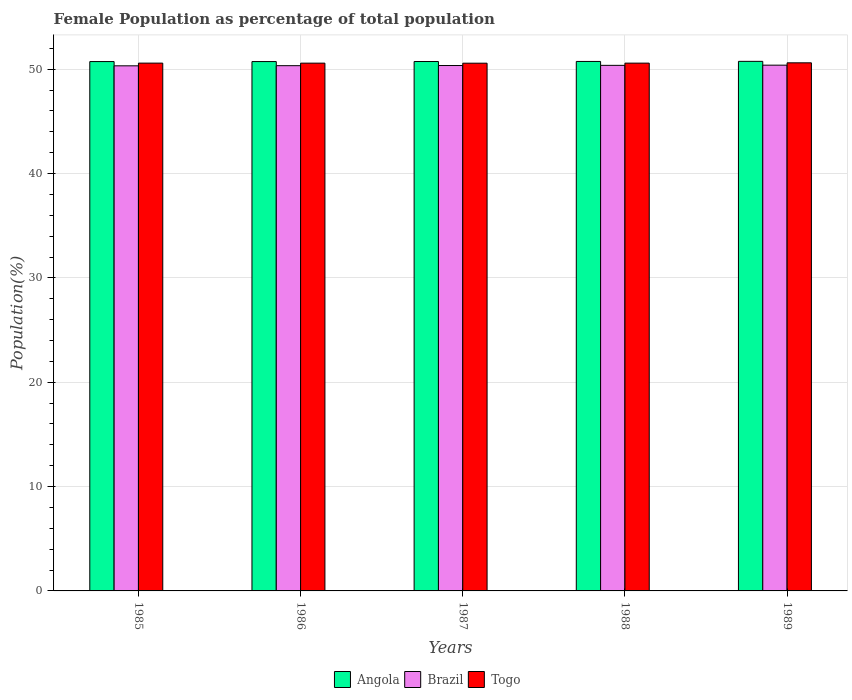Are the number of bars per tick equal to the number of legend labels?
Give a very brief answer. Yes. Are the number of bars on each tick of the X-axis equal?
Ensure brevity in your answer.  Yes. How many bars are there on the 4th tick from the left?
Provide a succinct answer. 3. What is the label of the 5th group of bars from the left?
Offer a very short reply. 1989. What is the female population in in Angola in 1989?
Your answer should be very brief. 50.75. Across all years, what is the maximum female population in in Brazil?
Ensure brevity in your answer.  50.39. Across all years, what is the minimum female population in in Brazil?
Offer a very short reply. 50.32. What is the total female population in in Brazil in the graph?
Keep it short and to the point. 251.77. What is the difference between the female population in in Angola in 1985 and that in 1989?
Provide a short and direct response. -0.02. What is the difference between the female population in in Brazil in 1987 and the female population in in Togo in 1985?
Offer a very short reply. -0.23. What is the average female population in in Angola per year?
Keep it short and to the point. 50.74. In the year 1988, what is the difference between the female population in in Brazil and female population in in Angola?
Ensure brevity in your answer.  -0.37. What is the ratio of the female population in in Brazil in 1985 to that in 1988?
Offer a very short reply. 1. Is the female population in in Angola in 1985 less than that in 1989?
Provide a short and direct response. Yes. Is the difference between the female population in in Brazil in 1985 and 1988 greater than the difference between the female population in in Angola in 1985 and 1988?
Keep it short and to the point. No. What is the difference between the highest and the second highest female population in in Brazil?
Provide a succinct answer. 0.02. What is the difference between the highest and the lowest female population in in Angola?
Your response must be concise. 0.02. Is the sum of the female population in in Angola in 1988 and 1989 greater than the maximum female population in in Brazil across all years?
Keep it short and to the point. Yes. What does the 3rd bar from the left in 1988 represents?
Ensure brevity in your answer.  Togo. What does the 1st bar from the right in 1989 represents?
Your answer should be compact. Togo. What is the difference between two consecutive major ticks on the Y-axis?
Offer a terse response. 10. Does the graph contain grids?
Make the answer very short. Yes. How are the legend labels stacked?
Offer a terse response. Horizontal. What is the title of the graph?
Keep it short and to the point. Female Population as percentage of total population. What is the label or title of the Y-axis?
Offer a very short reply. Population(%). What is the Population(%) of Angola in 1985?
Ensure brevity in your answer.  50.73. What is the Population(%) in Brazil in 1985?
Your answer should be compact. 50.32. What is the Population(%) of Togo in 1985?
Offer a terse response. 50.58. What is the Population(%) of Angola in 1986?
Offer a terse response. 50.73. What is the Population(%) in Brazil in 1986?
Provide a succinct answer. 50.34. What is the Population(%) of Togo in 1986?
Provide a short and direct response. 50.58. What is the Population(%) in Angola in 1987?
Offer a very short reply. 50.74. What is the Population(%) of Brazil in 1987?
Ensure brevity in your answer.  50.35. What is the Population(%) of Togo in 1987?
Your response must be concise. 50.58. What is the Population(%) of Angola in 1988?
Provide a succinct answer. 50.74. What is the Population(%) of Brazil in 1988?
Make the answer very short. 50.37. What is the Population(%) in Togo in 1988?
Your answer should be compact. 50.58. What is the Population(%) in Angola in 1989?
Provide a short and direct response. 50.75. What is the Population(%) in Brazil in 1989?
Your answer should be compact. 50.39. What is the Population(%) in Togo in 1989?
Provide a short and direct response. 50.61. Across all years, what is the maximum Population(%) of Angola?
Provide a succinct answer. 50.75. Across all years, what is the maximum Population(%) of Brazil?
Your answer should be compact. 50.39. Across all years, what is the maximum Population(%) in Togo?
Your response must be concise. 50.61. Across all years, what is the minimum Population(%) in Angola?
Ensure brevity in your answer.  50.73. Across all years, what is the minimum Population(%) in Brazil?
Offer a terse response. 50.32. Across all years, what is the minimum Population(%) in Togo?
Offer a very short reply. 50.58. What is the total Population(%) of Angola in the graph?
Your answer should be compact. 253.7. What is the total Population(%) in Brazil in the graph?
Your answer should be very brief. 251.77. What is the total Population(%) of Togo in the graph?
Give a very brief answer. 252.93. What is the difference between the Population(%) of Brazil in 1985 and that in 1986?
Offer a terse response. -0.01. What is the difference between the Population(%) in Togo in 1985 and that in 1986?
Give a very brief answer. 0. What is the difference between the Population(%) in Angola in 1985 and that in 1987?
Offer a terse response. -0. What is the difference between the Population(%) in Brazil in 1985 and that in 1987?
Ensure brevity in your answer.  -0.03. What is the difference between the Population(%) of Togo in 1985 and that in 1987?
Your answer should be compact. 0.01. What is the difference between the Population(%) in Angola in 1985 and that in 1988?
Offer a terse response. -0.01. What is the difference between the Population(%) of Brazil in 1985 and that in 1988?
Make the answer very short. -0.05. What is the difference between the Population(%) of Togo in 1985 and that in 1988?
Offer a terse response. 0. What is the difference between the Population(%) of Angola in 1985 and that in 1989?
Provide a succinct answer. -0.02. What is the difference between the Population(%) in Brazil in 1985 and that in 1989?
Your response must be concise. -0.06. What is the difference between the Population(%) of Togo in 1985 and that in 1989?
Your answer should be compact. -0.03. What is the difference between the Population(%) in Angola in 1986 and that in 1987?
Provide a short and direct response. -0. What is the difference between the Population(%) of Brazil in 1986 and that in 1987?
Make the answer very short. -0.02. What is the difference between the Population(%) in Togo in 1986 and that in 1987?
Provide a succinct answer. 0. What is the difference between the Population(%) of Angola in 1986 and that in 1988?
Ensure brevity in your answer.  -0.01. What is the difference between the Population(%) of Brazil in 1986 and that in 1988?
Your response must be concise. -0.03. What is the difference between the Population(%) of Togo in 1986 and that in 1988?
Provide a succinct answer. -0. What is the difference between the Population(%) in Angola in 1986 and that in 1989?
Offer a very short reply. -0.02. What is the difference between the Population(%) of Brazil in 1986 and that in 1989?
Your answer should be compact. -0.05. What is the difference between the Population(%) in Togo in 1986 and that in 1989?
Offer a very short reply. -0.03. What is the difference between the Population(%) of Angola in 1987 and that in 1988?
Give a very brief answer. -0.01. What is the difference between the Population(%) in Brazil in 1987 and that in 1988?
Ensure brevity in your answer.  -0.02. What is the difference between the Population(%) in Togo in 1987 and that in 1988?
Offer a very short reply. -0.01. What is the difference between the Population(%) in Angola in 1987 and that in 1989?
Your answer should be compact. -0.02. What is the difference between the Population(%) of Brazil in 1987 and that in 1989?
Ensure brevity in your answer.  -0.03. What is the difference between the Population(%) in Togo in 1987 and that in 1989?
Offer a very short reply. -0.04. What is the difference between the Population(%) of Angola in 1988 and that in 1989?
Give a very brief answer. -0.01. What is the difference between the Population(%) of Brazil in 1988 and that in 1989?
Give a very brief answer. -0.02. What is the difference between the Population(%) of Togo in 1988 and that in 1989?
Provide a short and direct response. -0.03. What is the difference between the Population(%) of Angola in 1985 and the Population(%) of Brazil in 1986?
Give a very brief answer. 0.39. What is the difference between the Population(%) of Angola in 1985 and the Population(%) of Togo in 1986?
Your response must be concise. 0.15. What is the difference between the Population(%) in Brazil in 1985 and the Population(%) in Togo in 1986?
Keep it short and to the point. -0.26. What is the difference between the Population(%) in Angola in 1985 and the Population(%) in Brazil in 1987?
Ensure brevity in your answer.  0.38. What is the difference between the Population(%) of Angola in 1985 and the Population(%) of Togo in 1987?
Provide a succinct answer. 0.16. What is the difference between the Population(%) of Brazil in 1985 and the Population(%) of Togo in 1987?
Offer a very short reply. -0.25. What is the difference between the Population(%) of Angola in 1985 and the Population(%) of Brazil in 1988?
Offer a very short reply. 0.36. What is the difference between the Population(%) of Angola in 1985 and the Population(%) of Togo in 1988?
Your answer should be very brief. 0.15. What is the difference between the Population(%) in Brazil in 1985 and the Population(%) in Togo in 1988?
Provide a succinct answer. -0.26. What is the difference between the Population(%) in Angola in 1985 and the Population(%) in Brazil in 1989?
Make the answer very short. 0.34. What is the difference between the Population(%) of Angola in 1985 and the Population(%) of Togo in 1989?
Your response must be concise. 0.12. What is the difference between the Population(%) in Brazil in 1985 and the Population(%) in Togo in 1989?
Keep it short and to the point. -0.29. What is the difference between the Population(%) of Angola in 1986 and the Population(%) of Brazil in 1987?
Your answer should be very brief. 0.38. What is the difference between the Population(%) of Angola in 1986 and the Population(%) of Togo in 1987?
Make the answer very short. 0.16. What is the difference between the Population(%) in Brazil in 1986 and the Population(%) in Togo in 1987?
Make the answer very short. -0.24. What is the difference between the Population(%) of Angola in 1986 and the Population(%) of Brazil in 1988?
Your answer should be very brief. 0.36. What is the difference between the Population(%) in Angola in 1986 and the Population(%) in Togo in 1988?
Provide a succinct answer. 0.15. What is the difference between the Population(%) in Brazil in 1986 and the Population(%) in Togo in 1988?
Ensure brevity in your answer.  -0.24. What is the difference between the Population(%) of Angola in 1986 and the Population(%) of Brazil in 1989?
Provide a short and direct response. 0.34. What is the difference between the Population(%) in Angola in 1986 and the Population(%) in Togo in 1989?
Your answer should be very brief. 0.12. What is the difference between the Population(%) of Brazil in 1986 and the Population(%) of Togo in 1989?
Your answer should be very brief. -0.27. What is the difference between the Population(%) of Angola in 1987 and the Population(%) of Brazil in 1988?
Offer a very short reply. 0.37. What is the difference between the Population(%) in Angola in 1987 and the Population(%) in Togo in 1988?
Keep it short and to the point. 0.15. What is the difference between the Population(%) of Brazil in 1987 and the Population(%) of Togo in 1988?
Offer a terse response. -0.23. What is the difference between the Population(%) of Angola in 1987 and the Population(%) of Brazil in 1989?
Offer a very short reply. 0.35. What is the difference between the Population(%) of Angola in 1987 and the Population(%) of Togo in 1989?
Provide a succinct answer. 0.12. What is the difference between the Population(%) in Brazil in 1987 and the Population(%) in Togo in 1989?
Ensure brevity in your answer.  -0.26. What is the difference between the Population(%) of Angola in 1988 and the Population(%) of Brazil in 1989?
Your answer should be compact. 0.36. What is the difference between the Population(%) of Angola in 1988 and the Population(%) of Togo in 1989?
Your response must be concise. 0.13. What is the difference between the Population(%) in Brazil in 1988 and the Population(%) in Togo in 1989?
Provide a short and direct response. -0.24. What is the average Population(%) of Angola per year?
Make the answer very short. 50.74. What is the average Population(%) in Brazil per year?
Give a very brief answer. 50.35. What is the average Population(%) in Togo per year?
Ensure brevity in your answer.  50.59. In the year 1985, what is the difference between the Population(%) of Angola and Population(%) of Brazil?
Provide a short and direct response. 0.41. In the year 1985, what is the difference between the Population(%) of Angola and Population(%) of Togo?
Offer a very short reply. 0.15. In the year 1985, what is the difference between the Population(%) in Brazil and Population(%) in Togo?
Your response must be concise. -0.26. In the year 1986, what is the difference between the Population(%) in Angola and Population(%) in Brazil?
Offer a very short reply. 0.39. In the year 1986, what is the difference between the Population(%) of Angola and Population(%) of Togo?
Offer a terse response. 0.15. In the year 1986, what is the difference between the Population(%) of Brazil and Population(%) of Togo?
Your answer should be compact. -0.24. In the year 1987, what is the difference between the Population(%) of Angola and Population(%) of Brazil?
Offer a very short reply. 0.38. In the year 1987, what is the difference between the Population(%) of Angola and Population(%) of Togo?
Your answer should be very brief. 0.16. In the year 1987, what is the difference between the Population(%) in Brazil and Population(%) in Togo?
Your answer should be very brief. -0.22. In the year 1988, what is the difference between the Population(%) of Angola and Population(%) of Brazil?
Ensure brevity in your answer.  0.37. In the year 1988, what is the difference between the Population(%) of Angola and Population(%) of Togo?
Offer a terse response. 0.16. In the year 1988, what is the difference between the Population(%) of Brazil and Population(%) of Togo?
Ensure brevity in your answer.  -0.21. In the year 1989, what is the difference between the Population(%) of Angola and Population(%) of Brazil?
Your answer should be compact. 0.36. In the year 1989, what is the difference between the Population(%) in Angola and Population(%) in Togo?
Provide a succinct answer. 0.14. In the year 1989, what is the difference between the Population(%) in Brazil and Population(%) in Togo?
Provide a succinct answer. -0.22. What is the ratio of the Population(%) in Togo in 1985 to that in 1986?
Offer a terse response. 1. What is the ratio of the Population(%) in Angola in 1985 to that in 1988?
Provide a short and direct response. 1. What is the ratio of the Population(%) of Brazil in 1985 to that in 1988?
Your answer should be very brief. 1. What is the ratio of the Population(%) of Togo in 1985 to that in 1988?
Make the answer very short. 1. What is the ratio of the Population(%) in Angola in 1985 to that in 1989?
Your answer should be very brief. 1. What is the ratio of the Population(%) in Brazil in 1985 to that in 1989?
Your answer should be very brief. 1. What is the ratio of the Population(%) in Angola in 1986 to that in 1987?
Make the answer very short. 1. What is the ratio of the Population(%) in Brazil in 1986 to that in 1987?
Make the answer very short. 1. What is the ratio of the Population(%) in Brazil in 1986 to that in 1988?
Keep it short and to the point. 1. What is the ratio of the Population(%) in Togo in 1986 to that in 1988?
Your answer should be compact. 1. What is the ratio of the Population(%) of Angola in 1986 to that in 1989?
Provide a short and direct response. 1. What is the ratio of the Population(%) of Togo in 1986 to that in 1989?
Make the answer very short. 1. What is the ratio of the Population(%) of Angola in 1987 to that in 1988?
Offer a terse response. 1. What is the ratio of the Population(%) in Angola in 1987 to that in 1989?
Ensure brevity in your answer.  1. What is the ratio of the Population(%) in Angola in 1988 to that in 1989?
Make the answer very short. 1. What is the ratio of the Population(%) in Brazil in 1988 to that in 1989?
Give a very brief answer. 1. What is the ratio of the Population(%) in Togo in 1988 to that in 1989?
Ensure brevity in your answer.  1. What is the difference between the highest and the second highest Population(%) in Angola?
Your response must be concise. 0.01. What is the difference between the highest and the second highest Population(%) in Brazil?
Keep it short and to the point. 0.02. What is the difference between the highest and the second highest Population(%) of Togo?
Keep it short and to the point. 0.03. What is the difference between the highest and the lowest Population(%) in Angola?
Offer a very short reply. 0.02. What is the difference between the highest and the lowest Population(%) in Brazil?
Your answer should be very brief. 0.06. What is the difference between the highest and the lowest Population(%) of Togo?
Your response must be concise. 0.04. 